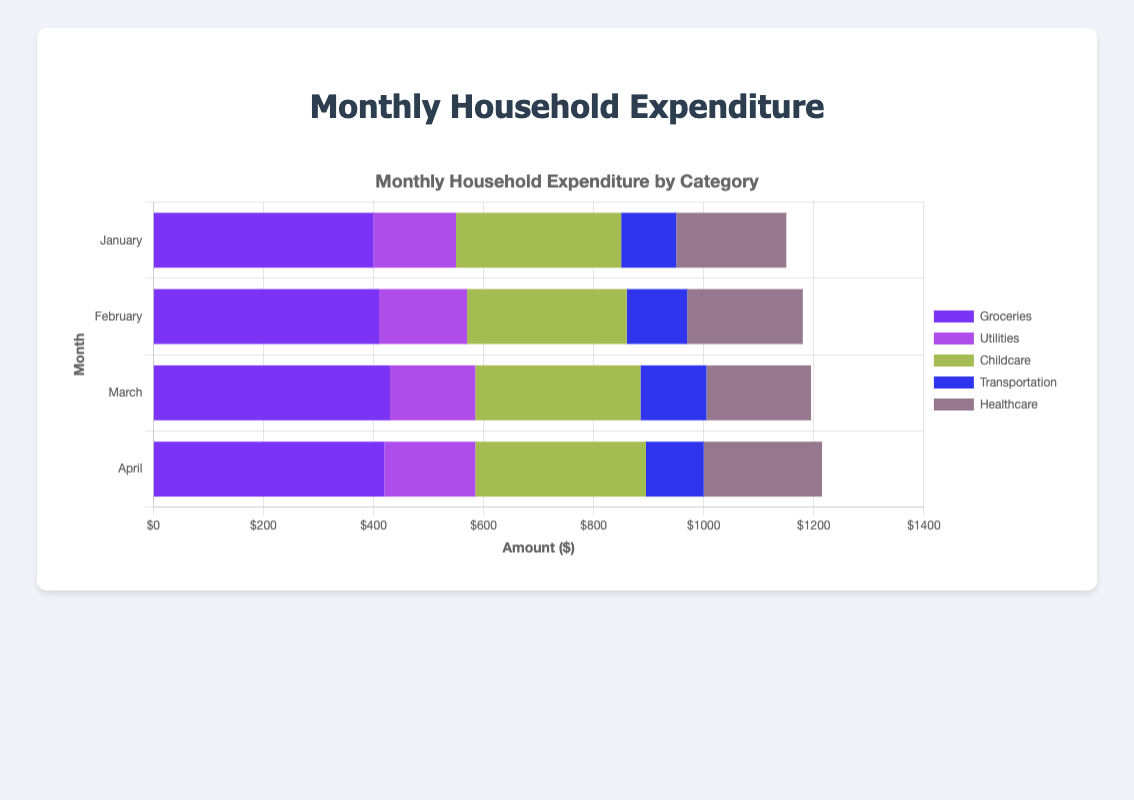What was the total expenditure on groceries in the first quarter (January to March)? Add the amounts spent on groceries in January, February, and March. Therefore, total expenditure = $400 (January) + $410 (February) + $430 (March) = $1240.
Answer: $1240 Which month had the highest total expenditure on all items combined? Calculate the overall expenditure for each month by summing up the amounts of all items for each month. January: $400 + $150 + $300 + $100 + $200 = $1150. February: $410 + $160 + $290 + $110 + $210 = $1180. March: $430 + $155 + $300 + $120 + $190 = $1195. April: $420 + $165 + $310 + $105 + $215 = $1215. Therefore, April had the highest total expenditure.
Answer: April By how much did childcare expenditure change from February to April? Subtract the expenditure in February from the expenditure in April. Therefore, change = $310 (April) - $290 (February) = $20.
Answer: $20 Which item had the most consistent monthly expenditure, judging by the visual lengths of their bars? Compare the lengths of the bars for each item. Utilities have bars of similar lengths across all months, implying the most consistent expenditure.
Answer: Utilities Which month had the highest expenditure on transportation, and by how much was it higher than the month with the lowest transportation expenditure? Identify the months and expenditures for transportation: January ($100), February ($110), March ($120), April ($105). March had the highest at $120, and January had the lowest at $100. The difference is $120 - $100 = $20.
Answer: March, $20 Did healthcare expenditure increase or decrease from January to April, and by how much? Subtract January's expenditure from April's expenditure for healthcare. Therefore, change = $215 (April) - $200 (January) = $15.
Answer: Increase, $15 Compare the total monthly expenditure on childcare and healthcare in March. Which one was higher and by how much? Childcare expenditure in March is $300, and healthcare expenditure in March is $190. The difference is $300 - $190 = $110.
Answer: Childcare, $110 What's the average monthly expenditure on utilities from January to April? Add the expenditures for utilities from January to April, then divide by the number of months. Therefore, average = ($150 + $160 + $155 + $165) / 4 = $630 / 4 = $157.5.
Answer: $157.5 